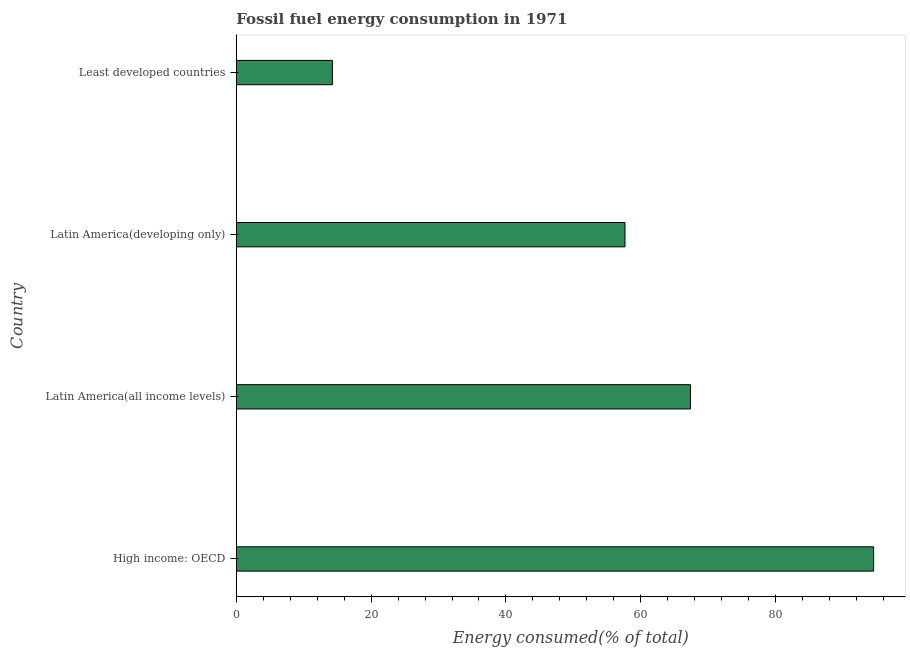What is the title of the graph?
Offer a very short reply. Fossil fuel energy consumption in 1971. What is the label or title of the X-axis?
Make the answer very short. Energy consumed(% of total). What is the label or title of the Y-axis?
Make the answer very short. Country. What is the fossil fuel energy consumption in High income: OECD?
Your answer should be very brief. 94.53. Across all countries, what is the maximum fossil fuel energy consumption?
Your answer should be very brief. 94.53. Across all countries, what is the minimum fossil fuel energy consumption?
Offer a very short reply. 14.26. In which country was the fossil fuel energy consumption maximum?
Ensure brevity in your answer.  High income: OECD. In which country was the fossil fuel energy consumption minimum?
Give a very brief answer. Least developed countries. What is the sum of the fossil fuel energy consumption?
Your answer should be compact. 233.82. What is the difference between the fossil fuel energy consumption in High income: OECD and Latin America(developing only)?
Give a very brief answer. 36.88. What is the average fossil fuel energy consumption per country?
Give a very brief answer. 58.45. What is the median fossil fuel energy consumption?
Ensure brevity in your answer.  62.51. What is the ratio of the fossil fuel energy consumption in Latin America(all income levels) to that in Least developed countries?
Provide a succinct answer. 4.72. Is the difference between the fossil fuel energy consumption in High income: OECD and Least developed countries greater than the difference between any two countries?
Ensure brevity in your answer.  Yes. What is the difference between the highest and the second highest fossil fuel energy consumption?
Your answer should be very brief. 27.17. Is the sum of the fossil fuel energy consumption in Latin America(developing only) and Least developed countries greater than the maximum fossil fuel energy consumption across all countries?
Make the answer very short. No. What is the difference between the highest and the lowest fossil fuel energy consumption?
Keep it short and to the point. 80.27. How many bars are there?
Your answer should be very brief. 4. How many countries are there in the graph?
Your answer should be very brief. 4. Are the values on the major ticks of X-axis written in scientific E-notation?
Give a very brief answer. No. What is the Energy consumed(% of total) of High income: OECD?
Your response must be concise. 94.53. What is the Energy consumed(% of total) of Latin America(all income levels)?
Your response must be concise. 67.37. What is the Energy consumed(% of total) in Latin America(developing only)?
Provide a succinct answer. 57.65. What is the Energy consumed(% of total) of Least developed countries?
Offer a very short reply. 14.26. What is the difference between the Energy consumed(% of total) in High income: OECD and Latin America(all income levels)?
Your answer should be very brief. 27.17. What is the difference between the Energy consumed(% of total) in High income: OECD and Latin America(developing only)?
Your answer should be compact. 36.88. What is the difference between the Energy consumed(% of total) in High income: OECD and Least developed countries?
Your answer should be compact. 80.27. What is the difference between the Energy consumed(% of total) in Latin America(all income levels) and Latin America(developing only)?
Ensure brevity in your answer.  9.71. What is the difference between the Energy consumed(% of total) in Latin America(all income levels) and Least developed countries?
Your answer should be compact. 53.11. What is the difference between the Energy consumed(% of total) in Latin America(developing only) and Least developed countries?
Give a very brief answer. 43.39. What is the ratio of the Energy consumed(% of total) in High income: OECD to that in Latin America(all income levels)?
Ensure brevity in your answer.  1.4. What is the ratio of the Energy consumed(% of total) in High income: OECD to that in Latin America(developing only)?
Your response must be concise. 1.64. What is the ratio of the Energy consumed(% of total) in High income: OECD to that in Least developed countries?
Ensure brevity in your answer.  6.63. What is the ratio of the Energy consumed(% of total) in Latin America(all income levels) to that in Latin America(developing only)?
Your answer should be compact. 1.17. What is the ratio of the Energy consumed(% of total) in Latin America(all income levels) to that in Least developed countries?
Offer a very short reply. 4.72. What is the ratio of the Energy consumed(% of total) in Latin America(developing only) to that in Least developed countries?
Give a very brief answer. 4.04. 